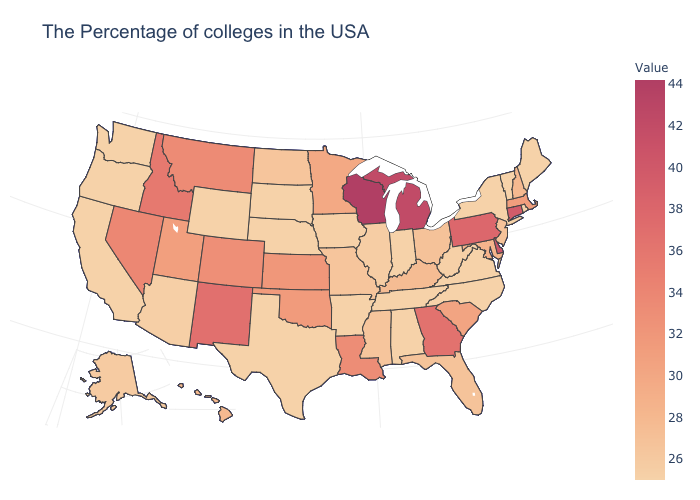Which states have the lowest value in the West?
Short answer required. Wyoming, California, Washington, Oregon. Which states hav the highest value in the Northeast?
Short answer required. Connecticut. 